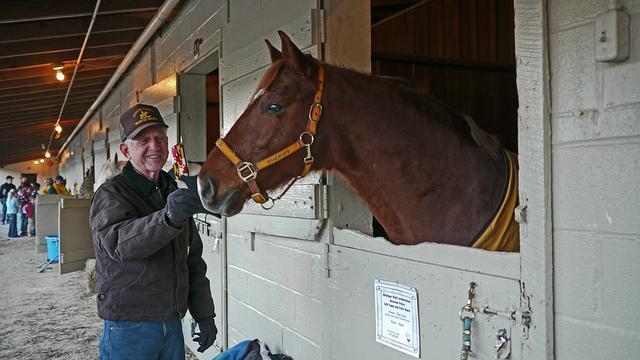How many trucks are there?
Give a very brief answer. 0. 